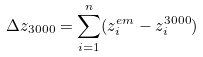<formula> <loc_0><loc_0><loc_500><loc_500>\Delta z _ { 3 0 0 0 } = \sum _ { i = 1 } ^ { n } ( z _ { i } ^ { e m } - z _ { i } ^ { 3 0 0 0 } )</formula> 